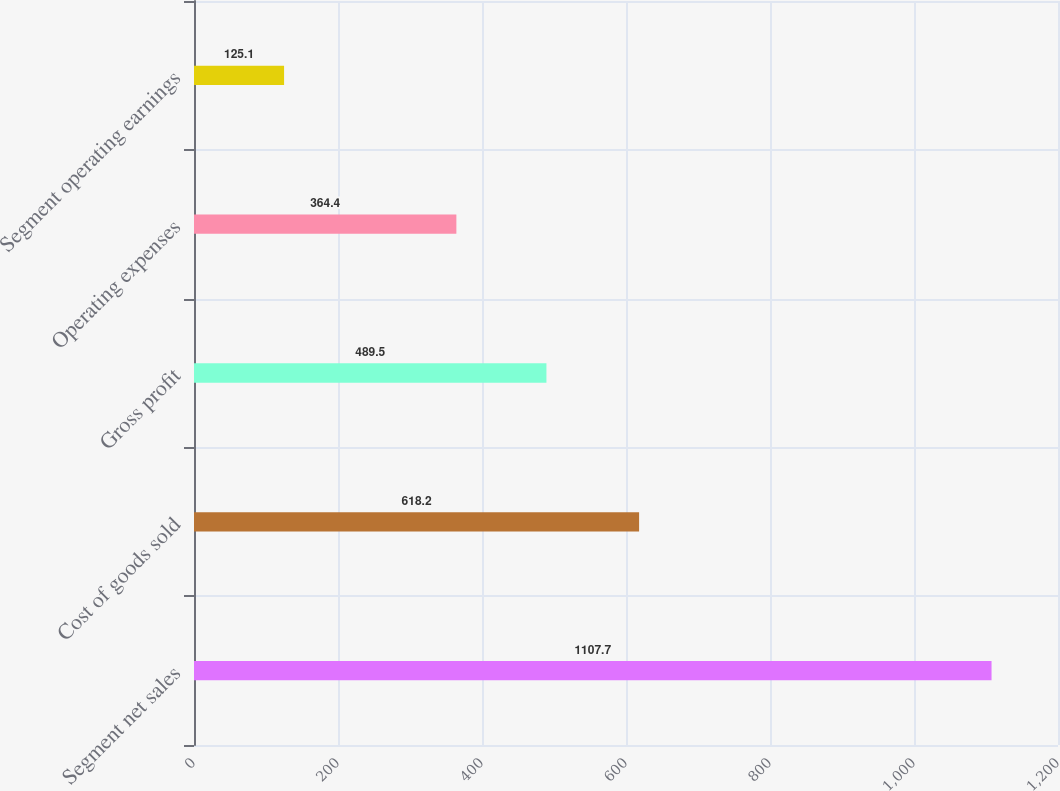<chart> <loc_0><loc_0><loc_500><loc_500><bar_chart><fcel>Segment net sales<fcel>Cost of goods sold<fcel>Gross profit<fcel>Operating expenses<fcel>Segment operating earnings<nl><fcel>1107.7<fcel>618.2<fcel>489.5<fcel>364.4<fcel>125.1<nl></chart> 